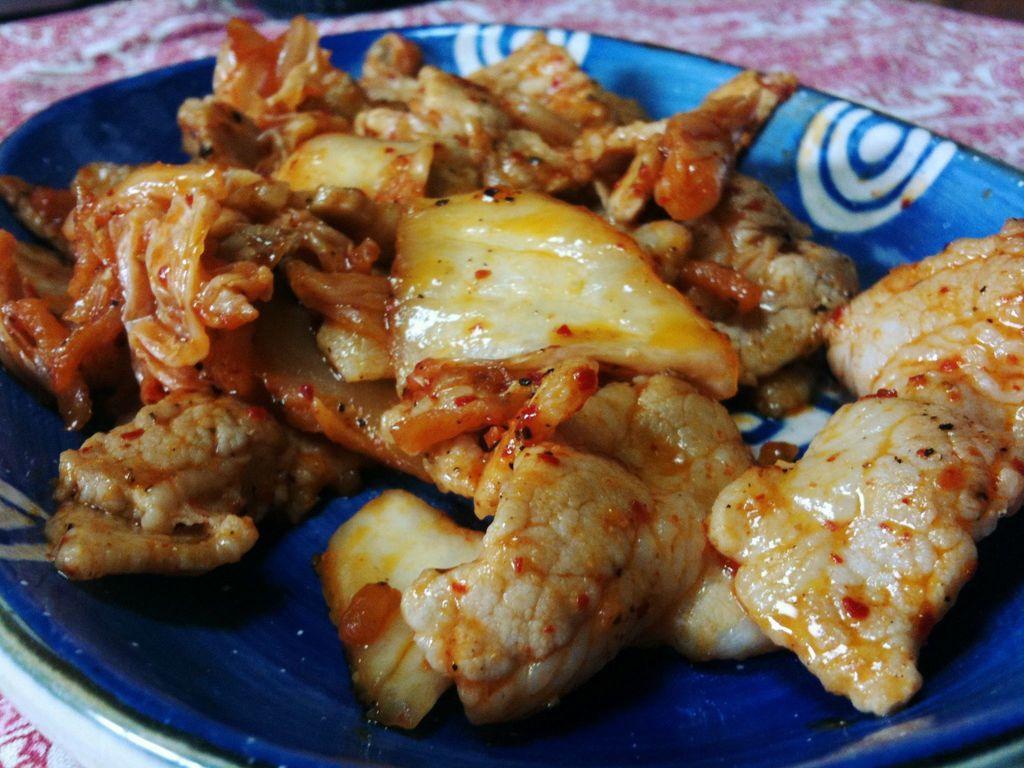How would you summarize this image in a sentence or two? In this picture I can observe some food places in the plate. The plate is in blue color. 